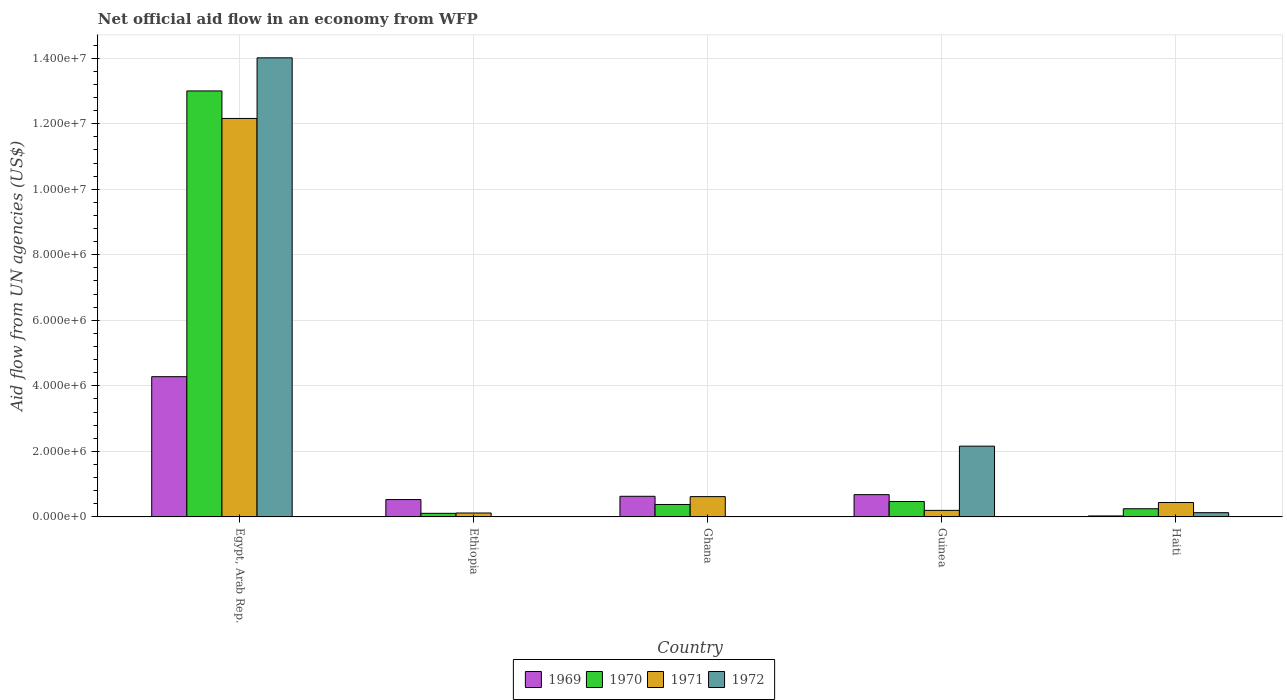How many different coloured bars are there?
Offer a very short reply. 4. Are the number of bars per tick equal to the number of legend labels?
Ensure brevity in your answer.  No. How many bars are there on the 3rd tick from the left?
Your answer should be compact. 3. What is the label of the 5th group of bars from the left?
Offer a terse response. Haiti. What is the net official aid flow in 1971 in Ghana?
Ensure brevity in your answer.  6.20e+05. Across all countries, what is the maximum net official aid flow in 1972?
Your answer should be compact. 1.40e+07. In which country was the net official aid flow in 1971 maximum?
Make the answer very short. Egypt, Arab Rep. What is the total net official aid flow in 1970 in the graph?
Your answer should be very brief. 1.42e+07. What is the difference between the net official aid flow in 1971 in Ethiopia and that in Guinea?
Your answer should be compact. -8.00e+04. What is the average net official aid flow in 1972 per country?
Provide a succinct answer. 3.26e+06. What is the difference between the net official aid flow of/in 1971 and net official aid flow of/in 1972 in Egypt, Arab Rep.?
Offer a very short reply. -1.85e+06. What is the ratio of the net official aid flow in 1970 in Egypt, Arab Rep. to that in Ghana?
Keep it short and to the point. 34.21. Is the net official aid flow in 1969 in Ghana less than that in Haiti?
Your response must be concise. No. What is the difference between the highest and the second highest net official aid flow in 1969?
Keep it short and to the point. 3.60e+06. What is the difference between the highest and the lowest net official aid flow in 1970?
Offer a terse response. 1.29e+07. In how many countries, is the net official aid flow in 1970 greater than the average net official aid flow in 1970 taken over all countries?
Give a very brief answer. 1. Is the sum of the net official aid flow in 1970 in Ethiopia and Haiti greater than the maximum net official aid flow in 1969 across all countries?
Offer a terse response. No. Is it the case that in every country, the sum of the net official aid flow in 1970 and net official aid flow in 1972 is greater than the sum of net official aid flow in 1971 and net official aid flow in 1969?
Give a very brief answer. No. Is it the case that in every country, the sum of the net official aid flow in 1972 and net official aid flow in 1969 is greater than the net official aid flow in 1971?
Offer a very short reply. No. Are all the bars in the graph horizontal?
Give a very brief answer. No. How many countries are there in the graph?
Your answer should be very brief. 5. Are the values on the major ticks of Y-axis written in scientific E-notation?
Give a very brief answer. Yes. Does the graph contain any zero values?
Your response must be concise. Yes. Where does the legend appear in the graph?
Provide a succinct answer. Bottom center. What is the title of the graph?
Give a very brief answer. Net official aid flow in an economy from WFP. What is the label or title of the X-axis?
Offer a very short reply. Country. What is the label or title of the Y-axis?
Make the answer very short. Aid flow from UN agencies (US$). What is the Aid flow from UN agencies (US$) in 1969 in Egypt, Arab Rep.?
Give a very brief answer. 4.28e+06. What is the Aid flow from UN agencies (US$) of 1970 in Egypt, Arab Rep.?
Your answer should be compact. 1.30e+07. What is the Aid flow from UN agencies (US$) in 1971 in Egypt, Arab Rep.?
Keep it short and to the point. 1.22e+07. What is the Aid flow from UN agencies (US$) in 1972 in Egypt, Arab Rep.?
Your response must be concise. 1.40e+07. What is the Aid flow from UN agencies (US$) in 1969 in Ethiopia?
Your response must be concise. 5.30e+05. What is the Aid flow from UN agencies (US$) of 1971 in Ethiopia?
Your response must be concise. 1.20e+05. What is the Aid flow from UN agencies (US$) of 1969 in Ghana?
Your response must be concise. 6.30e+05. What is the Aid flow from UN agencies (US$) in 1970 in Ghana?
Provide a short and direct response. 3.80e+05. What is the Aid flow from UN agencies (US$) of 1971 in Ghana?
Your answer should be very brief. 6.20e+05. What is the Aid flow from UN agencies (US$) in 1972 in Ghana?
Offer a terse response. 0. What is the Aid flow from UN agencies (US$) in 1969 in Guinea?
Keep it short and to the point. 6.80e+05. What is the Aid flow from UN agencies (US$) in 1972 in Guinea?
Your answer should be very brief. 2.16e+06. What is the Aid flow from UN agencies (US$) in 1969 in Haiti?
Your answer should be very brief. 3.00e+04. Across all countries, what is the maximum Aid flow from UN agencies (US$) of 1969?
Provide a short and direct response. 4.28e+06. Across all countries, what is the maximum Aid flow from UN agencies (US$) of 1970?
Ensure brevity in your answer.  1.30e+07. Across all countries, what is the maximum Aid flow from UN agencies (US$) in 1971?
Offer a very short reply. 1.22e+07. Across all countries, what is the maximum Aid flow from UN agencies (US$) of 1972?
Provide a short and direct response. 1.40e+07. Across all countries, what is the minimum Aid flow from UN agencies (US$) of 1969?
Your answer should be very brief. 3.00e+04. Across all countries, what is the minimum Aid flow from UN agencies (US$) in 1970?
Your answer should be very brief. 1.10e+05. What is the total Aid flow from UN agencies (US$) in 1969 in the graph?
Make the answer very short. 6.15e+06. What is the total Aid flow from UN agencies (US$) of 1970 in the graph?
Your answer should be compact. 1.42e+07. What is the total Aid flow from UN agencies (US$) in 1971 in the graph?
Give a very brief answer. 1.35e+07. What is the total Aid flow from UN agencies (US$) in 1972 in the graph?
Make the answer very short. 1.63e+07. What is the difference between the Aid flow from UN agencies (US$) in 1969 in Egypt, Arab Rep. and that in Ethiopia?
Your answer should be compact. 3.75e+06. What is the difference between the Aid flow from UN agencies (US$) of 1970 in Egypt, Arab Rep. and that in Ethiopia?
Provide a short and direct response. 1.29e+07. What is the difference between the Aid flow from UN agencies (US$) in 1971 in Egypt, Arab Rep. and that in Ethiopia?
Provide a short and direct response. 1.20e+07. What is the difference between the Aid flow from UN agencies (US$) in 1969 in Egypt, Arab Rep. and that in Ghana?
Keep it short and to the point. 3.65e+06. What is the difference between the Aid flow from UN agencies (US$) in 1970 in Egypt, Arab Rep. and that in Ghana?
Give a very brief answer. 1.26e+07. What is the difference between the Aid flow from UN agencies (US$) of 1971 in Egypt, Arab Rep. and that in Ghana?
Provide a short and direct response. 1.15e+07. What is the difference between the Aid flow from UN agencies (US$) in 1969 in Egypt, Arab Rep. and that in Guinea?
Give a very brief answer. 3.60e+06. What is the difference between the Aid flow from UN agencies (US$) in 1970 in Egypt, Arab Rep. and that in Guinea?
Offer a very short reply. 1.25e+07. What is the difference between the Aid flow from UN agencies (US$) in 1971 in Egypt, Arab Rep. and that in Guinea?
Your answer should be compact. 1.20e+07. What is the difference between the Aid flow from UN agencies (US$) in 1972 in Egypt, Arab Rep. and that in Guinea?
Provide a succinct answer. 1.18e+07. What is the difference between the Aid flow from UN agencies (US$) in 1969 in Egypt, Arab Rep. and that in Haiti?
Give a very brief answer. 4.25e+06. What is the difference between the Aid flow from UN agencies (US$) of 1970 in Egypt, Arab Rep. and that in Haiti?
Your answer should be compact. 1.28e+07. What is the difference between the Aid flow from UN agencies (US$) in 1971 in Egypt, Arab Rep. and that in Haiti?
Give a very brief answer. 1.17e+07. What is the difference between the Aid flow from UN agencies (US$) of 1972 in Egypt, Arab Rep. and that in Haiti?
Offer a terse response. 1.39e+07. What is the difference between the Aid flow from UN agencies (US$) of 1971 in Ethiopia and that in Ghana?
Offer a very short reply. -5.00e+05. What is the difference between the Aid flow from UN agencies (US$) in 1969 in Ethiopia and that in Guinea?
Your answer should be very brief. -1.50e+05. What is the difference between the Aid flow from UN agencies (US$) of 1970 in Ethiopia and that in Guinea?
Keep it short and to the point. -3.60e+05. What is the difference between the Aid flow from UN agencies (US$) in 1971 in Ethiopia and that in Guinea?
Your answer should be compact. -8.00e+04. What is the difference between the Aid flow from UN agencies (US$) in 1969 in Ethiopia and that in Haiti?
Make the answer very short. 5.00e+05. What is the difference between the Aid flow from UN agencies (US$) of 1970 in Ethiopia and that in Haiti?
Your response must be concise. -1.40e+05. What is the difference between the Aid flow from UN agencies (US$) in 1971 in Ethiopia and that in Haiti?
Offer a very short reply. -3.20e+05. What is the difference between the Aid flow from UN agencies (US$) of 1970 in Ghana and that in Guinea?
Give a very brief answer. -9.00e+04. What is the difference between the Aid flow from UN agencies (US$) in 1970 in Ghana and that in Haiti?
Give a very brief answer. 1.30e+05. What is the difference between the Aid flow from UN agencies (US$) in 1969 in Guinea and that in Haiti?
Your response must be concise. 6.50e+05. What is the difference between the Aid flow from UN agencies (US$) of 1970 in Guinea and that in Haiti?
Your response must be concise. 2.20e+05. What is the difference between the Aid flow from UN agencies (US$) in 1971 in Guinea and that in Haiti?
Give a very brief answer. -2.40e+05. What is the difference between the Aid flow from UN agencies (US$) of 1972 in Guinea and that in Haiti?
Your answer should be very brief. 2.03e+06. What is the difference between the Aid flow from UN agencies (US$) in 1969 in Egypt, Arab Rep. and the Aid flow from UN agencies (US$) in 1970 in Ethiopia?
Your answer should be compact. 4.17e+06. What is the difference between the Aid flow from UN agencies (US$) in 1969 in Egypt, Arab Rep. and the Aid flow from UN agencies (US$) in 1971 in Ethiopia?
Your answer should be compact. 4.16e+06. What is the difference between the Aid flow from UN agencies (US$) in 1970 in Egypt, Arab Rep. and the Aid flow from UN agencies (US$) in 1971 in Ethiopia?
Ensure brevity in your answer.  1.29e+07. What is the difference between the Aid flow from UN agencies (US$) in 1969 in Egypt, Arab Rep. and the Aid flow from UN agencies (US$) in 1970 in Ghana?
Your answer should be compact. 3.90e+06. What is the difference between the Aid flow from UN agencies (US$) of 1969 in Egypt, Arab Rep. and the Aid flow from UN agencies (US$) of 1971 in Ghana?
Your response must be concise. 3.66e+06. What is the difference between the Aid flow from UN agencies (US$) of 1970 in Egypt, Arab Rep. and the Aid flow from UN agencies (US$) of 1971 in Ghana?
Your response must be concise. 1.24e+07. What is the difference between the Aid flow from UN agencies (US$) of 1969 in Egypt, Arab Rep. and the Aid flow from UN agencies (US$) of 1970 in Guinea?
Your answer should be very brief. 3.81e+06. What is the difference between the Aid flow from UN agencies (US$) in 1969 in Egypt, Arab Rep. and the Aid flow from UN agencies (US$) in 1971 in Guinea?
Your response must be concise. 4.08e+06. What is the difference between the Aid flow from UN agencies (US$) in 1969 in Egypt, Arab Rep. and the Aid flow from UN agencies (US$) in 1972 in Guinea?
Your response must be concise. 2.12e+06. What is the difference between the Aid flow from UN agencies (US$) of 1970 in Egypt, Arab Rep. and the Aid flow from UN agencies (US$) of 1971 in Guinea?
Your answer should be very brief. 1.28e+07. What is the difference between the Aid flow from UN agencies (US$) in 1970 in Egypt, Arab Rep. and the Aid flow from UN agencies (US$) in 1972 in Guinea?
Offer a terse response. 1.08e+07. What is the difference between the Aid flow from UN agencies (US$) of 1969 in Egypt, Arab Rep. and the Aid flow from UN agencies (US$) of 1970 in Haiti?
Keep it short and to the point. 4.03e+06. What is the difference between the Aid flow from UN agencies (US$) in 1969 in Egypt, Arab Rep. and the Aid flow from UN agencies (US$) in 1971 in Haiti?
Make the answer very short. 3.84e+06. What is the difference between the Aid flow from UN agencies (US$) in 1969 in Egypt, Arab Rep. and the Aid flow from UN agencies (US$) in 1972 in Haiti?
Provide a succinct answer. 4.15e+06. What is the difference between the Aid flow from UN agencies (US$) in 1970 in Egypt, Arab Rep. and the Aid flow from UN agencies (US$) in 1971 in Haiti?
Give a very brief answer. 1.26e+07. What is the difference between the Aid flow from UN agencies (US$) in 1970 in Egypt, Arab Rep. and the Aid flow from UN agencies (US$) in 1972 in Haiti?
Your answer should be compact. 1.29e+07. What is the difference between the Aid flow from UN agencies (US$) in 1971 in Egypt, Arab Rep. and the Aid flow from UN agencies (US$) in 1972 in Haiti?
Give a very brief answer. 1.20e+07. What is the difference between the Aid flow from UN agencies (US$) of 1969 in Ethiopia and the Aid flow from UN agencies (US$) of 1971 in Ghana?
Offer a very short reply. -9.00e+04. What is the difference between the Aid flow from UN agencies (US$) of 1970 in Ethiopia and the Aid flow from UN agencies (US$) of 1971 in Ghana?
Keep it short and to the point. -5.10e+05. What is the difference between the Aid flow from UN agencies (US$) in 1969 in Ethiopia and the Aid flow from UN agencies (US$) in 1970 in Guinea?
Your answer should be compact. 6.00e+04. What is the difference between the Aid flow from UN agencies (US$) in 1969 in Ethiopia and the Aid flow from UN agencies (US$) in 1971 in Guinea?
Your response must be concise. 3.30e+05. What is the difference between the Aid flow from UN agencies (US$) of 1969 in Ethiopia and the Aid flow from UN agencies (US$) of 1972 in Guinea?
Give a very brief answer. -1.63e+06. What is the difference between the Aid flow from UN agencies (US$) in 1970 in Ethiopia and the Aid flow from UN agencies (US$) in 1971 in Guinea?
Give a very brief answer. -9.00e+04. What is the difference between the Aid flow from UN agencies (US$) in 1970 in Ethiopia and the Aid flow from UN agencies (US$) in 1972 in Guinea?
Offer a very short reply. -2.05e+06. What is the difference between the Aid flow from UN agencies (US$) of 1971 in Ethiopia and the Aid flow from UN agencies (US$) of 1972 in Guinea?
Make the answer very short. -2.04e+06. What is the difference between the Aid flow from UN agencies (US$) in 1969 in Ethiopia and the Aid flow from UN agencies (US$) in 1970 in Haiti?
Offer a very short reply. 2.80e+05. What is the difference between the Aid flow from UN agencies (US$) of 1970 in Ethiopia and the Aid flow from UN agencies (US$) of 1971 in Haiti?
Your response must be concise. -3.30e+05. What is the difference between the Aid flow from UN agencies (US$) in 1970 in Ethiopia and the Aid flow from UN agencies (US$) in 1972 in Haiti?
Your answer should be compact. -2.00e+04. What is the difference between the Aid flow from UN agencies (US$) of 1969 in Ghana and the Aid flow from UN agencies (US$) of 1970 in Guinea?
Your response must be concise. 1.60e+05. What is the difference between the Aid flow from UN agencies (US$) in 1969 in Ghana and the Aid flow from UN agencies (US$) in 1971 in Guinea?
Give a very brief answer. 4.30e+05. What is the difference between the Aid flow from UN agencies (US$) of 1969 in Ghana and the Aid flow from UN agencies (US$) of 1972 in Guinea?
Provide a short and direct response. -1.53e+06. What is the difference between the Aid flow from UN agencies (US$) of 1970 in Ghana and the Aid flow from UN agencies (US$) of 1971 in Guinea?
Provide a succinct answer. 1.80e+05. What is the difference between the Aid flow from UN agencies (US$) in 1970 in Ghana and the Aid flow from UN agencies (US$) in 1972 in Guinea?
Offer a terse response. -1.78e+06. What is the difference between the Aid flow from UN agencies (US$) in 1971 in Ghana and the Aid flow from UN agencies (US$) in 1972 in Guinea?
Provide a short and direct response. -1.54e+06. What is the difference between the Aid flow from UN agencies (US$) of 1969 in Ghana and the Aid flow from UN agencies (US$) of 1971 in Haiti?
Your answer should be compact. 1.90e+05. What is the difference between the Aid flow from UN agencies (US$) in 1969 in Ghana and the Aid flow from UN agencies (US$) in 1972 in Haiti?
Your answer should be very brief. 5.00e+05. What is the difference between the Aid flow from UN agencies (US$) of 1969 in Guinea and the Aid flow from UN agencies (US$) of 1970 in Haiti?
Provide a short and direct response. 4.30e+05. What is the difference between the Aid flow from UN agencies (US$) in 1969 in Guinea and the Aid flow from UN agencies (US$) in 1971 in Haiti?
Your answer should be very brief. 2.40e+05. What is the difference between the Aid flow from UN agencies (US$) in 1969 in Guinea and the Aid flow from UN agencies (US$) in 1972 in Haiti?
Your answer should be very brief. 5.50e+05. What is the difference between the Aid flow from UN agencies (US$) in 1971 in Guinea and the Aid flow from UN agencies (US$) in 1972 in Haiti?
Your answer should be very brief. 7.00e+04. What is the average Aid flow from UN agencies (US$) in 1969 per country?
Make the answer very short. 1.23e+06. What is the average Aid flow from UN agencies (US$) in 1970 per country?
Your answer should be very brief. 2.84e+06. What is the average Aid flow from UN agencies (US$) of 1971 per country?
Your response must be concise. 2.71e+06. What is the average Aid flow from UN agencies (US$) of 1972 per country?
Provide a short and direct response. 3.26e+06. What is the difference between the Aid flow from UN agencies (US$) of 1969 and Aid flow from UN agencies (US$) of 1970 in Egypt, Arab Rep.?
Your response must be concise. -8.72e+06. What is the difference between the Aid flow from UN agencies (US$) in 1969 and Aid flow from UN agencies (US$) in 1971 in Egypt, Arab Rep.?
Provide a succinct answer. -7.88e+06. What is the difference between the Aid flow from UN agencies (US$) in 1969 and Aid flow from UN agencies (US$) in 1972 in Egypt, Arab Rep.?
Your answer should be very brief. -9.73e+06. What is the difference between the Aid flow from UN agencies (US$) of 1970 and Aid flow from UN agencies (US$) of 1971 in Egypt, Arab Rep.?
Offer a terse response. 8.40e+05. What is the difference between the Aid flow from UN agencies (US$) of 1970 and Aid flow from UN agencies (US$) of 1972 in Egypt, Arab Rep.?
Give a very brief answer. -1.01e+06. What is the difference between the Aid flow from UN agencies (US$) of 1971 and Aid flow from UN agencies (US$) of 1972 in Egypt, Arab Rep.?
Ensure brevity in your answer.  -1.85e+06. What is the difference between the Aid flow from UN agencies (US$) of 1969 and Aid flow from UN agencies (US$) of 1971 in Ethiopia?
Offer a very short reply. 4.10e+05. What is the difference between the Aid flow from UN agencies (US$) of 1970 and Aid flow from UN agencies (US$) of 1971 in Ethiopia?
Provide a short and direct response. -10000. What is the difference between the Aid flow from UN agencies (US$) in 1969 and Aid flow from UN agencies (US$) in 1970 in Ghana?
Offer a terse response. 2.50e+05. What is the difference between the Aid flow from UN agencies (US$) in 1969 and Aid flow from UN agencies (US$) in 1972 in Guinea?
Ensure brevity in your answer.  -1.48e+06. What is the difference between the Aid flow from UN agencies (US$) in 1970 and Aid flow from UN agencies (US$) in 1971 in Guinea?
Ensure brevity in your answer.  2.70e+05. What is the difference between the Aid flow from UN agencies (US$) of 1970 and Aid flow from UN agencies (US$) of 1972 in Guinea?
Your response must be concise. -1.69e+06. What is the difference between the Aid flow from UN agencies (US$) in 1971 and Aid flow from UN agencies (US$) in 1972 in Guinea?
Offer a terse response. -1.96e+06. What is the difference between the Aid flow from UN agencies (US$) of 1969 and Aid flow from UN agencies (US$) of 1970 in Haiti?
Keep it short and to the point. -2.20e+05. What is the difference between the Aid flow from UN agencies (US$) in 1969 and Aid flow from UN agencies (US$) in 1971 in Haiti?
Offer a very short reply. -4.10e+05. What is the difference between the Aid flow from UN agencies (US$) in 1970 and Aid flow from UN agencies (US$) in 1971 in Haiti?
Keep it short and to the point. -1.90e+05. What is the difference between the Aid flow from UN agencies (US$) of 1970 and Aid flow from UN agencies (US$) of 1972 in Haiti?
Your answer should be very brief. 1.20e+05. What is the difference between the Aid flow from UN agencies (US$) in 1971 and Aid flow from UN agencies (US$) in 1972 in Haiti?
Keep it short and to the point. 3.10e+05. What is the ratio of the Aid flow from UN agencies (US$) in 1969 in Egypt, Arab Rep. to that in Ethiopia?
Provide a short and direct response. 8.08. What is the ratio of the Aid flow from UN agencies (US$) of 1970 in Egypt, Arab Rep. to that in Ethiopia?
Ensure brevity in your answer.  118.18. What is the ratio of the Aid flow from UN agencies (US$) of 1971 in Egypt, Arab Rep. to that in Ethiopia?
Make the answer very short. 101.33. What is the ratio of the Aid flow from UN agencies (US$) in 1969 in Egypt, Arab Rep. to that in Ghana?
Your response must be concise. 6.79. What is the ratio of the Aid flow from UN agencies (US$) of 1970 in Egypt, Arab Rep. to that in Ghana?
Offer a terse response. 34.21. What is the ratio of the Aid flow from UN agencies (US$) of 1971 in Egypt, Arab Rep. to that in Ghana?
Ensure brevity in your answer.  19.61. What is the ratio of the Aid flow from UN agencies (US$) in 1969 in Egypt, Arab Rep. to that in Guinea?
Ensure brevity in your answer.  6.29. What is the ratio of the Aid flow from UN agencies (US$) in 1970 in Egypt, Arab Rep. to that in Guinea?
Your answer should be compact. 27.66. What is the ratio of the Aid flow from UN agencies (US$) in 1971 in Egypt, Arab Rep. to that in Guinea?
Your answer should be compact. 60.8. What is the ratio of the Aid flow from UN agencies (US$) of 1972 in Egypt, Arab Rep. to that in Guinea?
Offer a terse response. 6.49. What is the ratio of the Aid flow from UN agencies (US$) in 1969 in Egypt, Arab Rep. to that in Haiti?
Give a very brief answer. 142.67. What is the ratio of the Aid flow from UN agencies (US$) in 1970 in Egypt, Arab Rep. to that in Haiti?
Provide a short and direct response. 52. What is the ratio of the Aid flow from UN agencies (US$) of 1971 in Egypt, Arab Rep. to that in Haiti?
Offer a terse response. 27.64. What is the ratio of the Aid flow from UN agencies (US$) in 1972 in Egypt, Arab Rep. to that in Haiti?
Offer a very short reply. 107.77. What is the ratio of the Aid flow from UN agencies (US$) of 1969 in Ethiopia to that in Ghana?
Your response must be concise. 0.84. What is the ratio of the Aid flow from UN agencies (US$) of 1970 in Ethiopia to that in Ghana?
Your answer should be very brief. 0.29. What is the ratio of the Aid flow from UN agencies (US$) in 1971 in Ethiopia to that in Ghana?
Provide a succinct answer. 0.19. What is the ratio of the Aid flow from UN agencies (US$) of 1969 in Ethiopia to that in Guinea?
Your answer should be compact. 0.78. What is the ratio of the Aid flow from UN agencies (US$) in 1970 in Ethiopia to that in Guinea?
Ensure brevity in your answer.  0.23. What is the ratio of the Aid flow from UN agencies (US$) of 1971 in Ethiopia to that in Guinea?
Offer a very short reply. 0.6. What is the ratio of the Aid flow from UN agencies (US$) of 1969 in Ethiopia to that in Haiti?
Your answer should be compact. 17.67. What is the ratio of the Aid flow from UN agencies (US$) of 1970 in Ethiopia to that in Haiti?
Give a very brief answer. 0.44. What is the ratio of the Aid flow from UN agencies (US$) in 1971 in Ethiopia to that in Haiti?
Offer a very short reply. 0.27. What is the ratio of the Aid flow from UN agencies (US$) of 1969 in Ghana to that in Guinea?
Provide a short and direct response. 0.93. What is the ratio of the Aid flow from UN agencies (US$) of 1970 in Ghana to that in Guinea?
Offer a terse response. 0.81. What is the ratio of the Aid flow from UN agencies (US$) in 1969 in Ghana to that in Haiti?
Provide a succinct answer. 21. What is the ratio of the Aid flow from UN agencies (US$) in 1970 in Ghana to that in Haiti?
Ensure brevity in your answer.  1.52. What is the ratio of the Aid flow from UN agencies (US$) of 1971 in Ghana to that in Haiti?
Make the answer very short. 1.41. What is the ratio of the Aid flow from UN agencies (US$) in 1969 in Guinea to that in Haiti?
Your answer should be compact. 22.67. What is the ratio of the Aid flow from UN agencies (US$) in 1970 in Guinea to that in Haiti?
Provide a succinct answer. 1.88. What is the ratio of the Aid flow from UN agencies (US$) of 1971 in Guinea to that in Haiti?
Your answer should be compact. 0.45. What is the ratio of the Aid flow from UN agencies (US$) in 1972 in Guinea to that in Haiti?
Give a very brief answer. 16.62. What is the difference between the highest and the second highest Aid flow from UN agencies (US$) of 1969?
Your answer should be compact. 3.60e+06. What is the difference between the highest and the second highest Aid flow from UN agencies (US$) of 1970?
Provide a succinct answer. 1.25e+07. What is the difference between the highest and the second highest Aid flow from UN agencies (US$) of 1971?
Make the answer very short. 1.15e+07. What is the difference between the highest and the second highest Aid flow from UN agencies (US$) in 1972?
Keep it short and to the point. 1.18e+07. What is the difference between the highest and the lowest Aid flow from UN agencies (US$) in 1969?
Ensure brevity in your answer.  4.25e+06. What is the difference between the highest and the lowest Aid flow from UN agencies (US$) in 1970?
Provide a short and direct response. 1.29e+07. What is the difference between the highest and the lowest Aid flow from UN agencies (US$) of 1971?
Provide a short and direct response. 1.20e+07. What is the difference between the highest and the lowest Aid flow from UN agencies (US$) in 1972?
Give a very brief answer. 1.40e+07. 